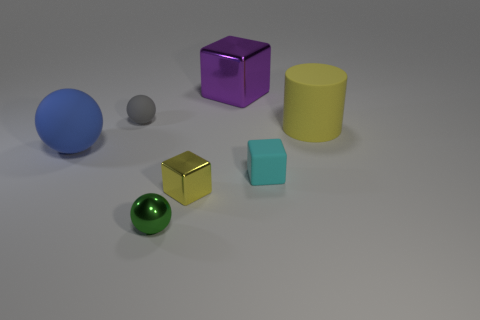Is there anything else that has the same shape as the small green metallic object?
Ensure brevity in your answer.  Yes. Is the small cyan object the same shape as the tiny yellow shiny thing?
Keep it short and to the point. Yes. Are there the same number of large yellow matte cylinders behind the small yellow metallic thing and green metallic balls that are behind the tiny gray matte ball?
Keep it short and to the point. No. What number of other objects are the same material as the yellow cylinder?
Your answer should be very brief. 3. What number of big objects are gray objects or yellow metal things?
Offer a terse response. 0. Are there the same number of big yellow objects left of the large purple shiny thing and shiny blocks?
Your response must be concise. No. There is a metal block that is behind the blue matte sphere; are there any large balls behind it?
Make the answer very short. No. How many other things are the same color as the large block?
Ensure brevity in your answer.  0. What is the color of the rubber cube?
Ensure brevity in your answer.  Cyan. What is the size of the rubber object that is both behind the blue matte object and on the left side of the large rubber cylinder?
Provide a short and direct response. Small. 